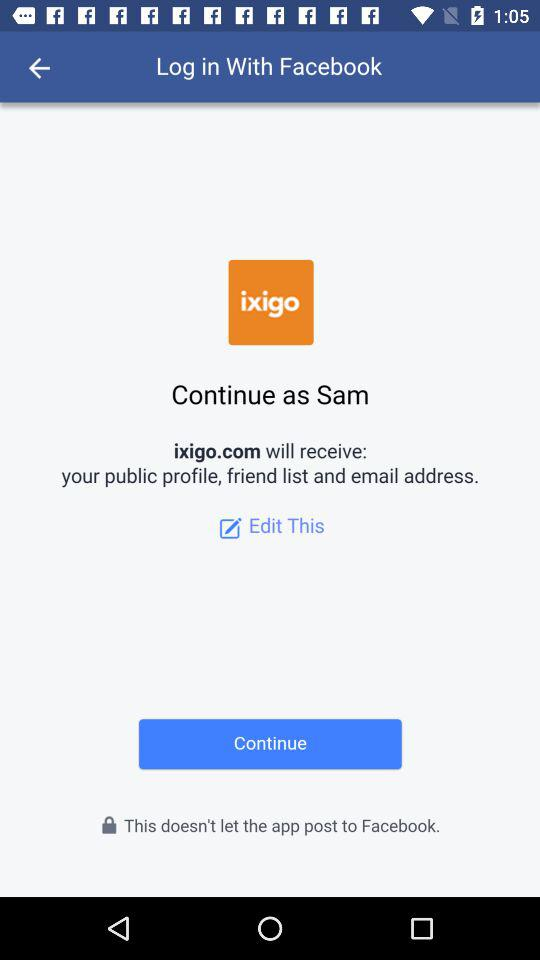What is the user name? The user name is Sam. 